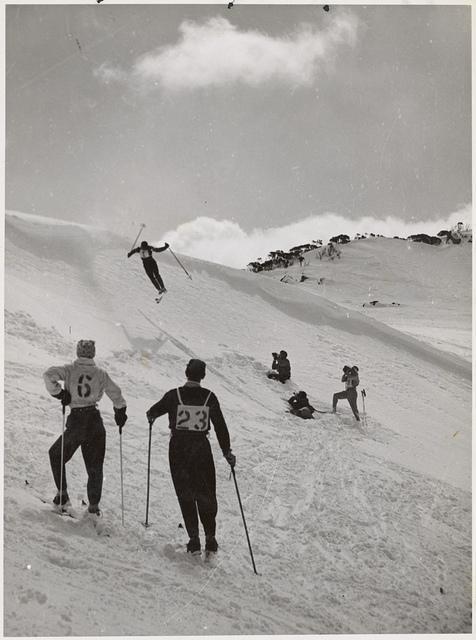How many photographers are there?
Give a very brief answer. 3. How many people are there?
Give a very brief answer. 2. How many chairs are there?
Give a very brief answer. 0. 